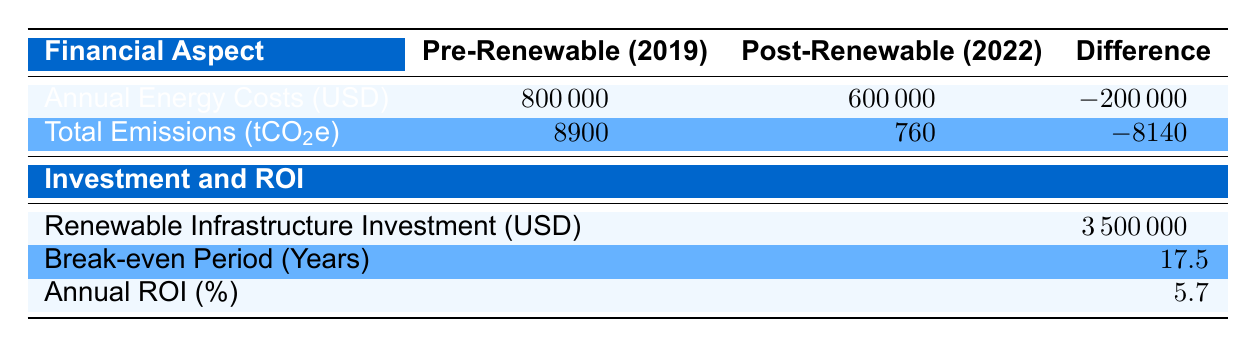What were the total emissions before adopting renewable energy? The table indicates that the total emissions before renewable energy adoption were 8900 tCO2e.
Answer: 8900 tCO2e What was the annual energy cost after adopting renewable energy? According to the table, the annual energy cost after adopting renewable energy was 600000 USD.
Answer: 600000 USD Did the adoption of renewable energy lead to a reduction in total emissions? Yes, the change in total emissions shows a decrease from 8900 tCO2e to 760 tCO2e, confirming a reduction.
Answer: Yes What is the difference in annual energy costs before and after adopting renewable energy? The table provides the annual energy costs of 800000 USD (pre-renewable) and 600000 USD (post-renewable), leading to a difference of 800000 - 600000 = 200000 USD.
Answer: 200000 USD How many years will it take to break even on the investment made for renewable infrastructure? The table states that the break-even period for the renewable infrastructure investment is 17.5 years.
Answer: 17.5 years What is the total savings achieved from adopting renewable energy? The table indicates a total savings of 200000 USD after transitioning to renewable energy.
Answer: 200000 USD Is the annual ROI higher or lower than 5 percent? The annual ROI is reported as 5.7 percent, which is higher than 5 percent.
Answer: Higher What is the total emissions reduction achieved after the renewable energy shift? The emissions reduced from 8900 tCO2e to 760 tCO2e, indicated by the table, making the total emissions reduction 8900 - 760 = 8140 tCO2e.
Answer: 8140 tCO2e How much was invested in renewable infrastructure? The investment in renewable infrastructure is stated as 3500000 USD in the table.
Answer: 3500000 USD 